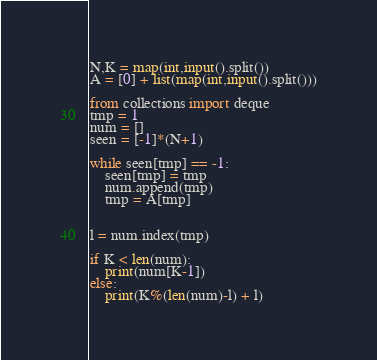<code> <loc_0><loc_0><loc_500><loc_500><_Python_>N,K = map(int,input().split())
A = [0] + list(map(int,input().split()))

from collections import deque 
tmp = 1
num = []
seen = [-1]*(N+1)
 
while seen[tmp] == -1:
    seen[tmp] = tmp
    num.append(tmp)
    tmp = A[tmp]


l = num.index(tmp)

if K < len(num):
    print(num[K-1])
else:
    print(K%(len(num)-l) + l)</code> 